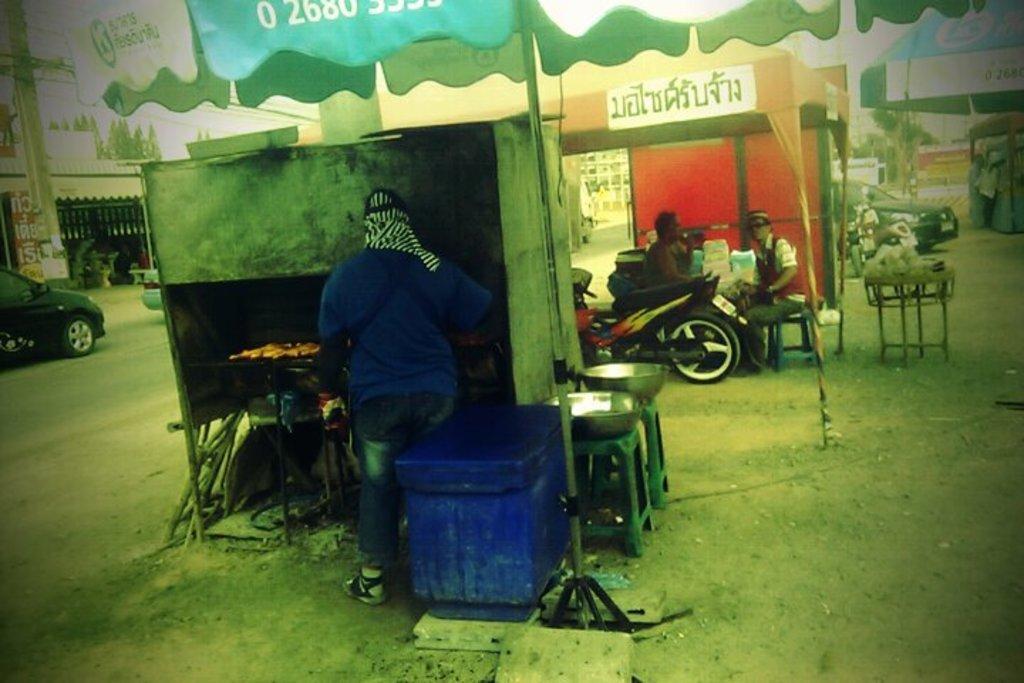How would you summarize this image in a sentence or two? In this picture I can see few stalls in front and I see few people and I see the stools on which there are few things and I see a bike. In the background I see few buildings and few cars and I see the cloth on top of this picture, on which there is something written. 